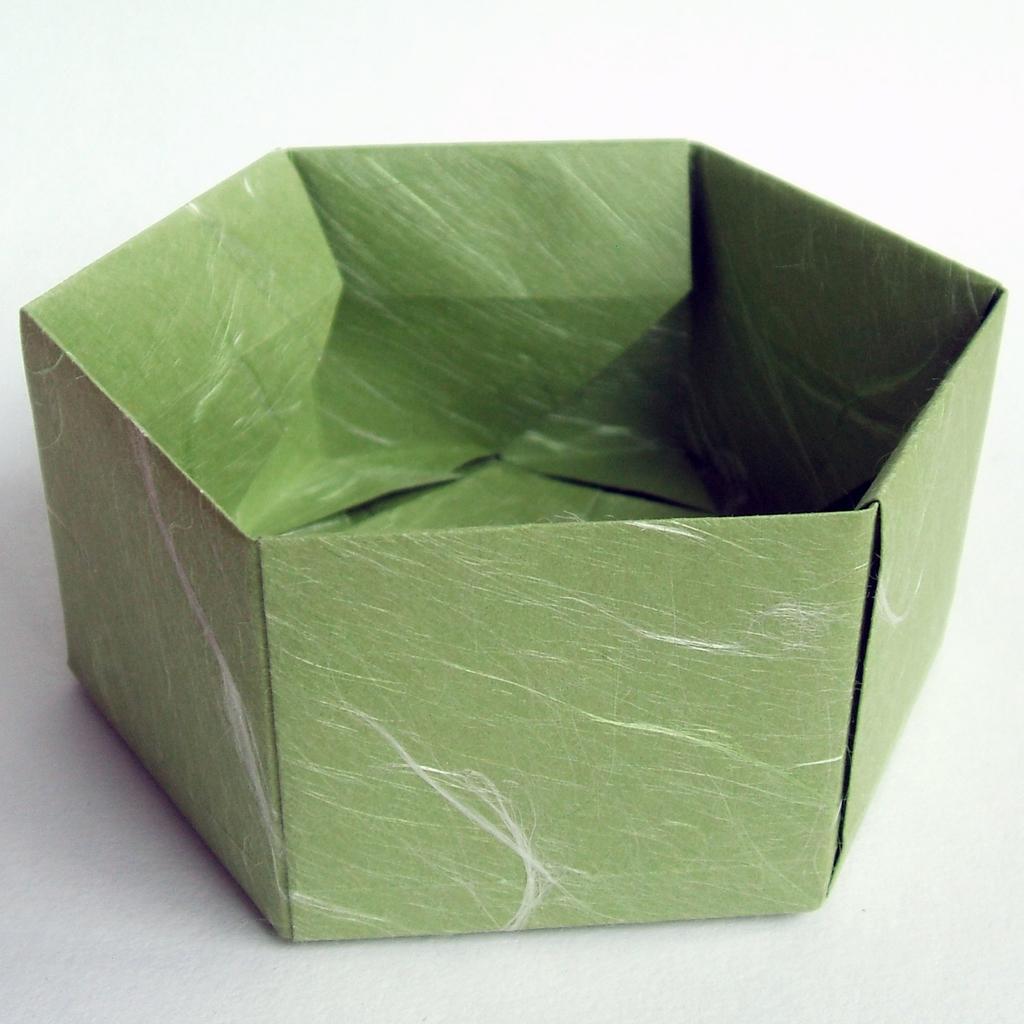Can you describe this image briefly? In this image, we can see a craft on the white surface. 